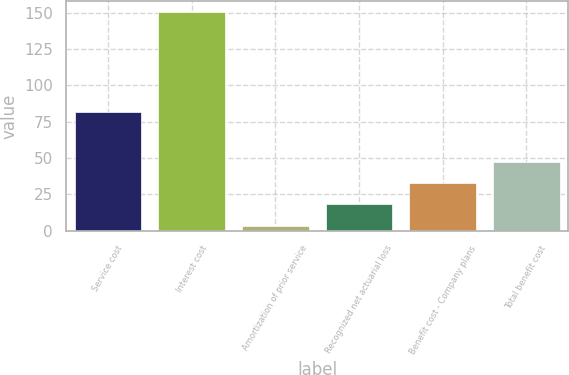Convert chart to OTSL. <chart><loc_0><loc_0><loc_500><loc_500><bar_chart><fcel>Service cost<fcel>Interest cost<fcel>Amortization of prior service<fcel>Recognized net actuarial loss<fcel>Benefit cost - Company plans<fcel>Total benefit cost<nl><fcel>81.8<fcel>150.1<fcel>3.6<fcel>18.25<fcel>32.9<fcel>47.55<nl></chart> 